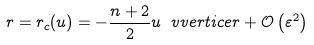Convert formula to latex. <formula><loc_0><loc_0><loc_500><loc_500>r = r _ { c } ( u ) = - \frac { n + 2 } { 2 } u \ v v e r t i c e r + \mathcal { O } \left ( \varepsilon ^ { 2 } \right )</formula> 